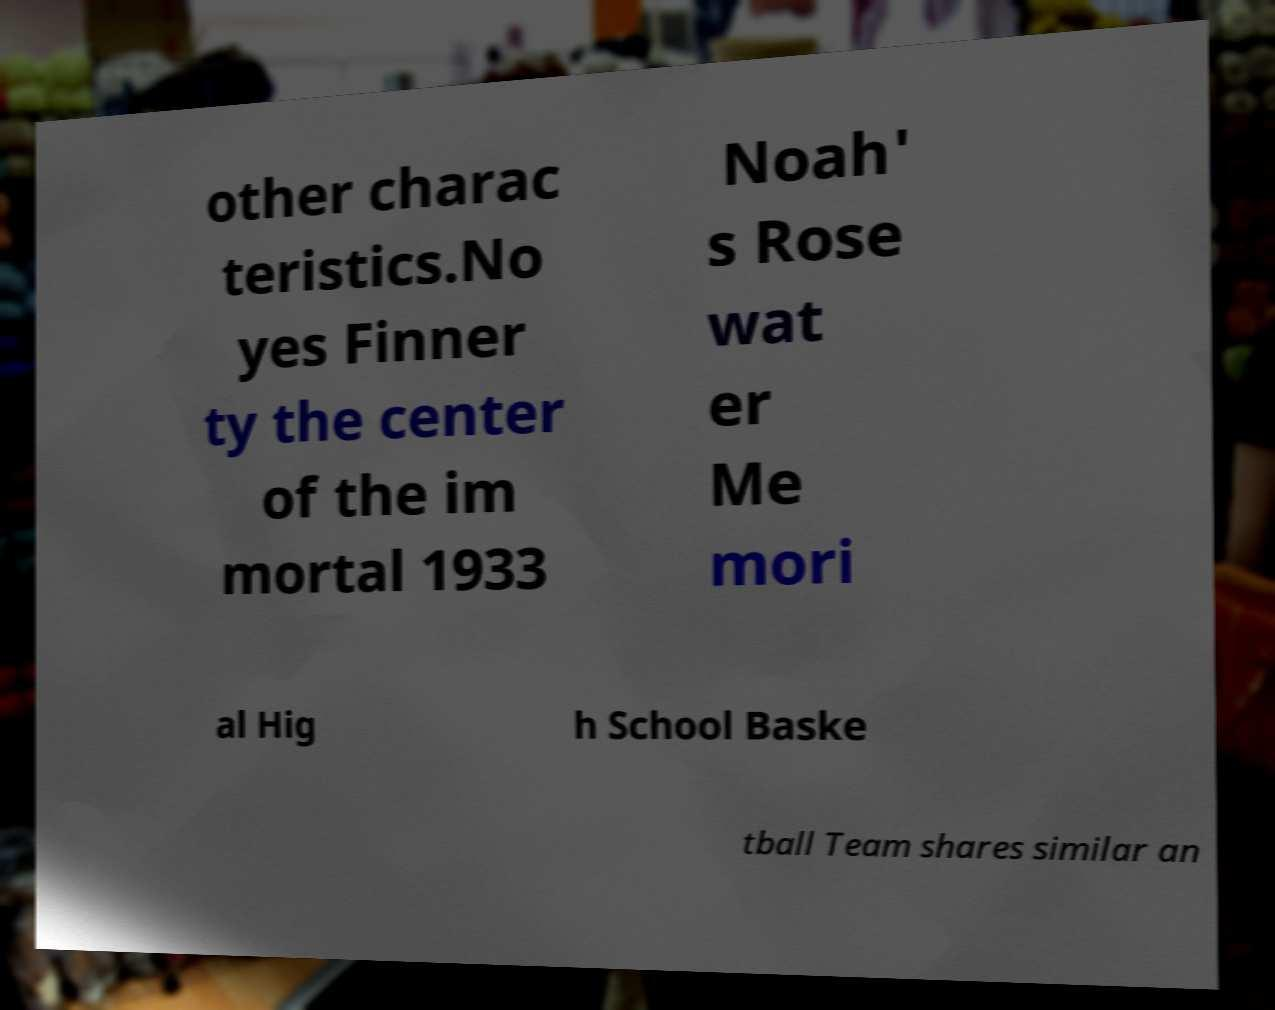Can you read and provide the text displayed in the image?This photo seems to have some interesting text. Can you extract and type it out for me? other charac teristics.No yes Finner ty the center of the im mortal 1933 Noah' s Rose wat er Me mori al Hig h School Baske tball Team shares similar an 